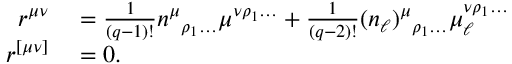<formula> <loc_0><loc_0><loc_500><loc_500>\begin{array} { r l } { r ^ { \mu \nu } } & = \frac { 1 } { ( q - 1 ) ! } n ^ { \mu _ { \rho _ { 1 } \dots } \mu ^ { \nu \rho _ { 1 } \dots } + \frac { 1 } { ( q - 2 ) ! } ( n _ { \ell } ) ^ { \mu _ { \rho _ { 1 } \dots } \mu _ { \ell } ^ { \nu \rho _ { 1 } \dots } } \\ { r ^ { [ \mu \nu ] } } & = 0 . } \end{array}</formula> 